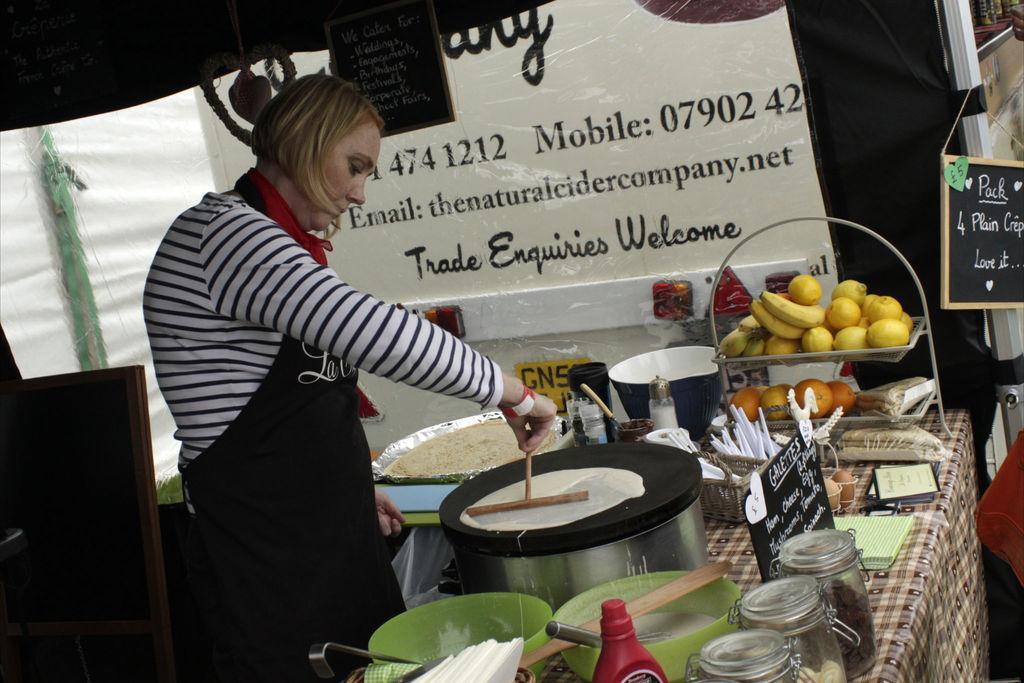In one or two sentences, can you explain what this image depicts? In this picture we can see a person holding a stick, here we can see a table, bowls, jars, basket, tissue papers, name boards, fruits, banner and some objects. 